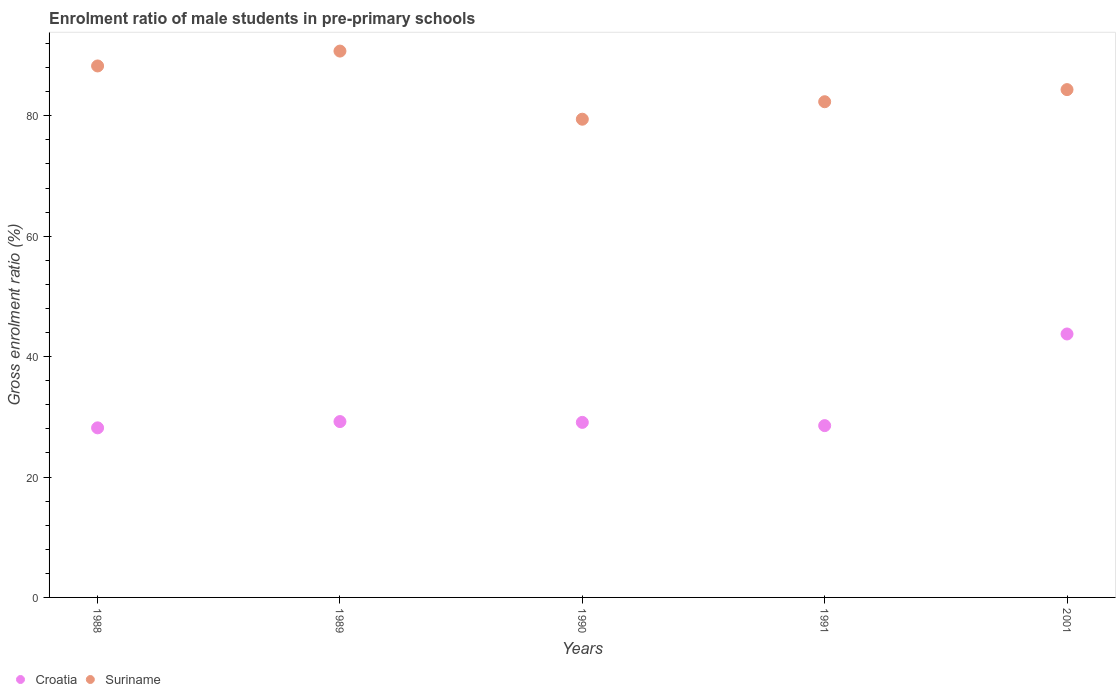How many different coloured dotlines are there?
Provide a short and direct response. 2. Is the number of dotlines equal to the number of legend labels?
Give a very brief answer. Yes. What is the enrolment ratio of male students in pre-primary schools in Suriname in 1988?
Your answer should be compact. 88.28. Across all years, what is the maximum enrolment ratio of male students in pre-primary schools in Suriname?
Offer a very short reply. 90.75. Across all years, what is the minimum enrolment ratio of male students in pre-primary schools in Suriname?
Ensure brevity in your answer.  79.44. What is the total enrolment ratio of male students in pre-primary schools in Croatia in the graph?
Keep it short and to the point. 158.76. What is the difference between the enrolment ratio of male students in pre-primary schools in Suriname in 1990 and that in 2001?
Give a very brief answer. -4.92. What is the difference between the enrolment ratio of male students in pre-primary schools in Croatia in 1991 and the enrolment ratio of male students in pre-primary schools in Suriname in 1990?
Give a very brief answer. -50.9. What is the average enrolment ratio of male students in pre-primary schools in Croatia per year?
Offer a terse response. 31.75. In the year 1991, what is the difference between the enrolment ratio of male students in pre-primary schools in Suriname and enrolment ratio of male students in pre-primary schools in Croatia?
Keep it short and to the point. 53.8. What is the ratio of the enrolment ratio of male students in pre-primary schools in Suriname in 1990 to that in 2001?
Keep it short and to the point. 0.94. Is the enrolment ratio of male students in pre-primary schools in Croatia in 1989 less than that in 1991?
Provide a succinct answer. No. What is the difference between the highest and the second highest enrolment ratio of male students in pre-primary schools in Croatia?
Offer a very short reply. 14.55. What is the difference between the highest and the lowest enrolment ratio of male students in pre-primary schools in Croatia?
Give a very brief answer. 15.59. In how many years, is the enrolment ratio of male students in pre-primary schools in Suriname greater than the average enrolment ratio of male students in pre-primary schools in Suriname taken over all years?
Offer a very short reply. 2. Does the enrolment ratio of male students in pre-primary schools in Suriname monotonically increase over the years?
Your answer should be compact. No. Is the enrolment ratio of male students in pre-primary schools in Croatia strictly greater than the enrolment ratio of male students in pre-primary schools in Suriname over the years?
Offer a very short reply. No. Is the enrolment ratio of male students in pre-primary schools in Suriname strictly less than the enrolment ratio of male students in pre-primary schools in Croatia over the years?
Offer a terse response. No. How many years are there in the graph?
Ensure brevity in your answer.  5. Are the values on the major ticks of Y-axis written in scientific E-notation?
Provide a short and direct response. No. Does the graph contain any zero values?
Offer a very short reply. No. Does the graph contain grids?
Keep it short and to the point. No. What is the title of the graph?
Offer a terse response. Enrolment ratio of male students in pre-primary schools. Does "Israel" appear as one of the legend labels in the graph?
Provide a succinct answer. No. What is the label or title of the X-axis?
Your answer should be very brief. Years. What is the label or title of the Y-axis?
Keep it short and to the point. Gross enrolment ratio (%). What is the Gross enrolment ratio (%) in Croatia in 1988?
Keep it short and to the point. 28.17. What is the Gross enrolment ratio (%) of Suriname in 1988?
Offer a terse response. 88.28. What is the Gross enrolment ratio (%) of Croatia in 1989?
Keep it short and to the point. 29.21. What is the Gross enrolment ratio (%) of Suriname in 1989?
Provide a short and direct response. 90.75. What is the Gross enrolment ratio (%) of Croatia in 1990?
Offer a very short reply. 29.08. What is the Gross enrolment ratio (%) of Suriname in 1990?
Keep it short and to the point. 79.44. What is the Gross enrolment ratio (%) of Croatia in 1991?
Make the answer very short. 28.54. What is the Gross enrolment ratio (%) of Suriname in 1991?
Your answer should be compact. 82.34. What is the Gross enrolment ratio (%) in Croatia in 2001?
Give a very brief answer. 43.76. What is the Gross enrolment ratio (%) in Suriname in 2001?
Your response must be concise. 84.35. Across all years, what is the maximum Gross enrolment ratio (%) in Croatia?
Offer a very short reply. 43.76. Across all years, what is the maximum Gross enrolment ratio (%) in Suriname?
Your answer should be very brief. 90.75. Across all years, what is the minimum Gross enrolment ratio (%) in Croatia?
Ensure brevity in your answer.  28.17. Across all years, what is the minimum Gross enrolment ratio (%) in Suriname?
Keep it short and to the point. 79.44. What is the total Gross enrolment ratio (%) of Croatia in the graph?
Give a very brief answer. 158.76. What is the total Gross enrolment ratio (%) of Suriname in the graph?
Your response must be concise. 425.17. What is the difference between the Gross enrolment ratio (%) in Croatia in 1988 and that in 1989?
Offer a very short reply. -1.04. What is the difference between the Gross enrolment ratio (%) in Suriname in 1988 and that in 1989?
Your response must be concise. -2.47. What is the difference between the Gross enrolment ratio (%) in Croatia in 1988 and that in 1990?
Your answer should be compact. -0.91. What is the difference between the Gross enrolment ratio (%) of Suriname in 1988 and that in 1990?
Your response must be concise. 8.85. What is the difference between the Gross enrolment ratio (%) in Croatia in 1988 and that in 1991?
Offer a very short reply. -0.37. What is the difference between the Gross enrolment ratio (%) of Suriname in 1988 and that in 1991?
Ensure brevity in your answer.  5.94. What is the difference between the Gross enrolment ratio (%) of Croatia in 1988 and that in 2001?
Offer a terse response. -15.59. What is the difference between the Gross enrolment ratio (%) in Suriname in 1988 and that in 2001?
Make the answer very short. 3.93. What is the difference between the Gross enrolment ratio (%) in Croatia in 1989 and that in 1990?
Provide a succinct answer. 0.14. What is the difference between the Gross enrolment ratio (%) of Suriname in 1989 and that in 1990?
Ensure brevity in your answer.  11.32. What is the difference between the Gross enrolment ratio (%) of Croatia in 1989 and that in 1991?
Give a very brief answer. 0.67. What is the difference between the Gross enrolment ratio (%) of Suriname in 1989 and that in 1991?
Give a very brief answer. 8.41. What is the difference between the Gross enrolment ratio (%) in Croatia in 1989 and that in 2001?
Offer a very short reply. -14.55. What is the difference between the Gross enrolment ratio (%) of Suriname in 1989 and that in 2001?
Offer a very short reply. 6.4. What is the difference between the Gross enrolment ratio (%) of Croatia in 1990 and that in 1991?
Provide a short and direct response. 0.54. What is the difference between the Gross enrolment ratio (%) of Suriname in 1990 and that in 1991?
Give a very brief answer. -2.9. What is the difference between the Gross enrolment ratio (%) of Croatia in 1990 and that in 2001?
Offer a terse response. -14.69. What is the difference between the Gross enrolment ratio (%) in Suriname in 1990 and that in 2001?
Offer a very short reply. -4.92. What is the difference between the Gross enrolment ratio (%) in Croatia in 1991 and that in 2001?
Keep it short and to the point. -15.22. What is the difference between the Gross enrolment ratio (%) of Suriname in 1991 and that in 2001?
Your response must be concise. -2.01. What is the difference between the Gross enrolment ratio (%) in Croatia in 1988 and the Gross enrolment ratio (%) in Suriname in 1989?
Provide a succinct answer. -62.58. What is the difference between the Gross enrolment ratio (%) in Croatia in 1988 and the Gross enrolment ratio (%) in Suriname in 1990?
Keep it short and to the point. -51.27. What is the difference between the Gross enrolment ratio (%) of Croatia in 1988 and the Gross enrolment ratio (%) of Suriname in 1991?
Your response must be concise. -54.17. What is the difference between the Gross enrolment ratio (%) of Croatia in 1988 and the Gross enrolment ratio (%) of Suriname in 2001?
Make the answer very short. -56.18. What is the difference between the Gross enrolment ratio (%) of Croatia in 1989 and the Gross enrolment ratio (%) of Suriname in 1990?
Give a very brief answer. -50.23. What is the difference between the Gross enrolment ratio (%) of Croatia in 1989 and the Gross enrolment ratio (%) of Suriname in 1991?
Ensure brevity in your answer.  -53.13. What is the difference between the Gross enrolment ratio (%) of Croatia in 1989 and the Gross enrolment ratio (%) of Suriname in 2001?
Ensure brevity in your answer.  -55.14. What is the difference between the Gross enrolment ratio (%) in Croatia in 1990 and the Gross enrolment ratio (%) in Suriname in 1991?
Ensure brevity in your answer.  -53.27. What is the difference between the Gross enrolment ratio (%) in Croatia in 1990 and the Gross enrolment ratio (%) in Suriname in 2001?
Make the answer very short. -55.28. What is the difference between the Gross enrolment ratio (%) in Croatia in 1991 and the Gross enrolment ratio (%) in Suriname in 2001?
Your response must be concise. -55.82. What is the average Gross enrolment ratio (%) of Croatia per year?
Provide a succinct answer. 31.75. What is the average Gross enrolment ratio (%) in Suriname per year?
Your response must be concise. 85.03. In the year 1988, what is the difference between the Gross enrolment ratio (%) of Croatia and Gross enrolment ratio (%) of Suriname?
Ensure brevity in your answer.  -60.11. In the year 1989, what is the difference between the Gross enrolment ratio (%) of Croatia and Gross enrolment ratio (%) of Suriname?
Your answer should be very brief. -61.54. In the year 1990, what is the difference between the Gross enrolment ratio (%) of Croatia and Gross enrolment ratio (%) of Suriname?
Provide a short and direct response. -50.36. In the year 1991, what is the difference between the Gross enrolment ratio (%) in Croatia and Gross enrolment ratio (%) in Suriname?
Give a very brief answer. -53.8. In the year 2001, what is the difference between the Gross enrolment ratio (%) in Croatia and Gross enrolment ratio (%) in Suriname?
Your answer should be compact. -40.59. What is the ratio of the Gross enrolment ratio (%) in Croatia in 1988 to that in 1989?
Offer a terse response. 0.96. What is the ratio of the Gross enrolment ratio (%) in Suriname in 1988 to that in 1989?
Make the answer very short. 0.97. What is the ratio of the Gross enrolment ratio (%) in Croatia in 1988 to that in 1990?
Your answer should be very brief. 0.97. What is the ratio of the Gross enrolment ratio (%) in Suriname in 1988 to that in 1990?
Provide a succinct answer. 1.11. What is the ratio of the Gross enrolment ratio (%) in Croatia in 1988 to that in 1991?
Give a very brief answer. 0.99. What is the ratio of the Gross enrolment ratio (%) in Suriname in 1988 to that in 1991?
Your response must be concise. 1.07. What is the ratio of the Gross enrolment ratio (%) of Croatia in 1988 to that in 2001?
Provide a short and direct response. 0.64. What is the ratio of the Gross enrolment ratio (%) in Suriname in 1988 to that in 2001?
Ensure brevity in your answer.  1.05. What is the ratio of the Gross enrolment ratio (%) in Croatia in 1989 to that in 1990?
Your answer should be compact. 1. What is the ratio of the Gross enrolment ratio (%) of Suriname in 1989 to that in 1990?
Ensure brevity in your answer.  1.14. What is the ratio of the Gross enrolment ratio (%) in Croatia in 1989 to that in 1991?
Offer a very short reply. 1.02. What is the ratio of the Gross enrolment ratio (%) in Suriname in 1989 to that in 1991?
Your response must be concise. 1.1. What is the ratio of the Gross enrolment ratio (%) of Croatia in 1989 to that in 2001?
Offer a terse response. 0.67. What is the ratio of the Gross enrolment ratio (%) in Suriname in 1989 to that in 2001?
Your answer should be compact. 1.08. What is the ratio of the Gross enrolment ratio (%) of Croatia in 1990 to that in 1991?
Offer a terse response. 1.02. What is the ratio of the Gross enrolment ratio (%) in Suriname in 1990 to that in 1991?
Provide a succinct answer. 0.96. What is the ratio of the Gross enrolment ratio (%) of Croatia in 1990 to that in 2001?
Keep it short and to the point. 0.66. What is the ratio of the Gross enrolment ratio (%) of Suriname in 1990 to that in 2001?
Your answer should be very brief. 0.94. What is the ratio of the Gross enrolment ratio (%) in Croatia in 1991 to that in 2001?
Make the answer very short. 0.65. What is the ratio of the Gross enrolment ratio (%) in Suriname in 1991 to that in 2001?
Give a very brief answer. 0.98. What is the difference between the highest and the second highest Gross enrolment ratio (%) in Croatia?
Offer a very short reply. 14.55. What is the difference between the highest and the second highest Gross enrolment ratio (%) in Suriname?
Make the answer very short. 2.47. What is the difference between the highest and the lowest Gross enrolment ratio (%) of Croatia?
Provide a short and direct response. 15.59. What is the difference between the highest and the lowest Gross enrolment ratio (%) of Suriname?
Give a very brief answer. 11.32. 